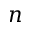<formula> <loc_0><loc_0><loc_500><loc_500>n</formula> 